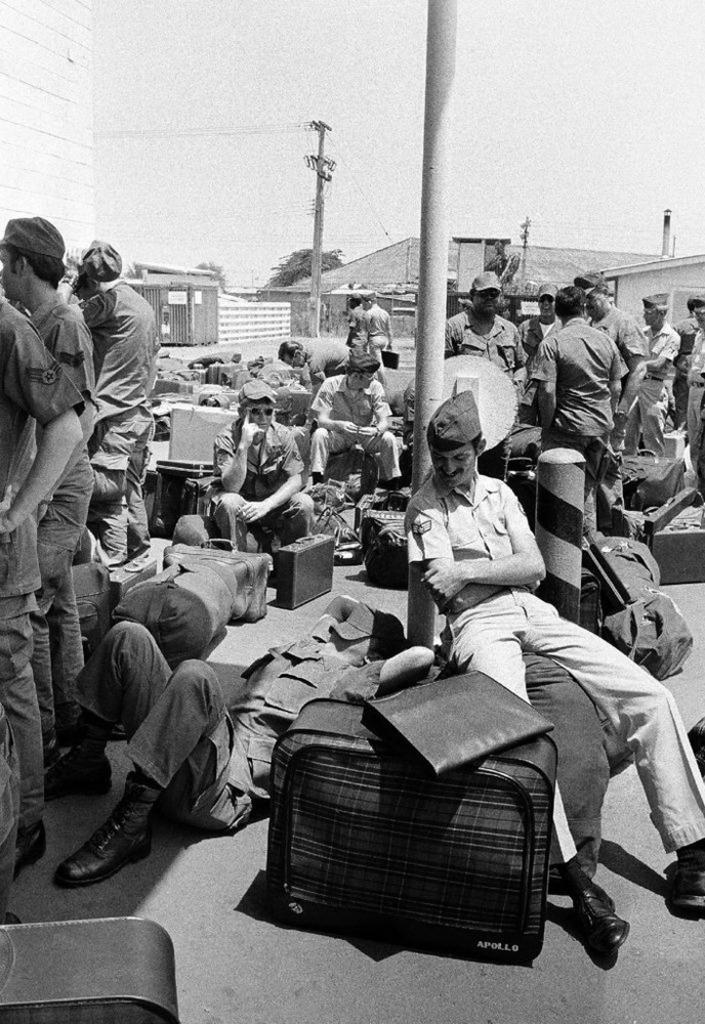Could you give a brief overview of what you see in this image? This is a black and white photographic image of a few officers, standing and sitting on the floor with luggage, in the background of the image there are trees, houses and utility poles. 